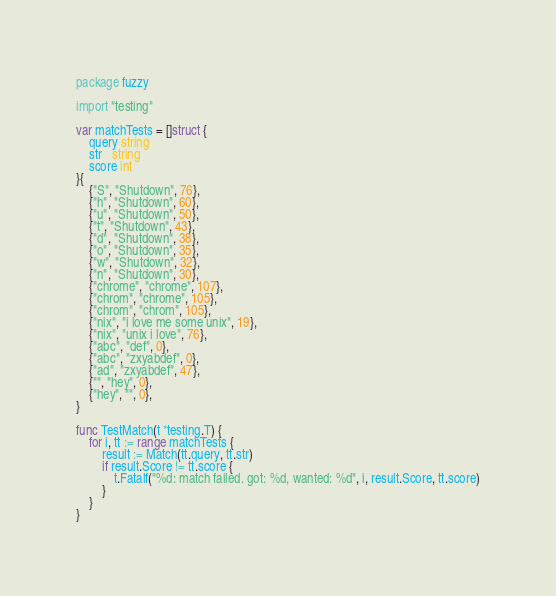<code> <loc_0><loc_0><loc_500><loc_500><_Go_>package fuzzy

import "testing"

var matchTests = []struct {
	query string
	str   string
	score int
}{
	{"S", "Shutdown", 76},
	{"h", "Shutdown", 60},
	{"u", "Shutdown", 50},
	{"t", "Shutdown", 43},
	{"d", "Shutdown", 38},
	{"o", "Shutdown", 35},
	{"w", "Shutdown", 32},
	{"n", "Shutdown", 30},
	{"chrome", "chrome", 107},
	{"chrom", "chrome", 105},
	{"chrom", "chrom", 105},
	{"nix", "i love me some unix", 19},
	{"nix", "unix i love", 76},
	{"abc", "def", 0},
	{"abc", "zxyabdef", 0},
	{"ad", "zxyabdef", 47},
	{"", "hey", 0},
	{"hey", "", 0},
}

func TestMatch(t *testing.T) {
	for i, tt := range matchTests {
		result := Match(tt.query, tt.str)
		if result.Score != tt.score {
			t.Fatalf("%d: match failed. got: %d, wanted: %d", i, result.Score, tt.score)
		}
	}
}
</code> 